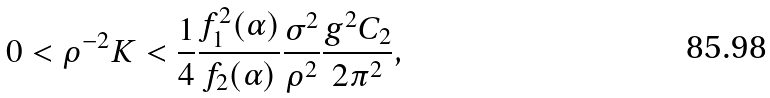Convert formula to latex. <formula><loc_0><loc_0><loc_500><loc_500>0 < \rho ^ { - 2 } K < { \frac { 1 } { 4 } } { \frac { f _ { 1 } ^ { 2 } ( \alpha ) } { f _ { 2 } ( \alpha ) } } { \frac { \sigma ^ { 2 } } { \rho ^ { 2 } } } { \frac { g ^ { 2 } C _ { 2 } } { 2 \pi ^ { 2 } } } ,</formula> 